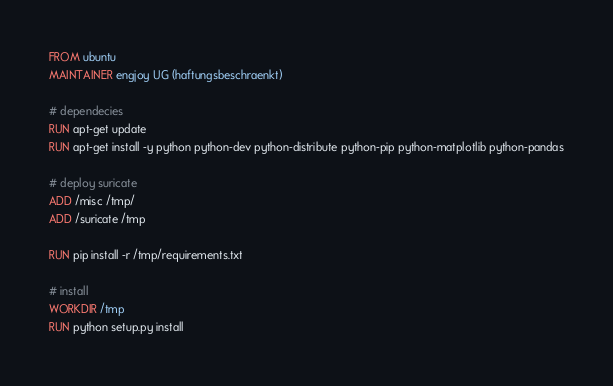Convert code to text. <code><loc_0><loc_0><loc_500><loc_500><_Dockerfile_>FROM ubuntu
MAINTAINER engjoy UG (haftungsbeschraenkt)

# dependecies
RUN apt-get update
RUN apt-get install -y python python-dev python-distribute python-pip python-matplotlib python-pandas

# deploy suricate
ADD /misc /tmp/
ADD /suricate /tmp

RUN pip install -r /tmp/requirements.txt

# install
WORKDIR /tmp
RUN python setup.py install
</code> 